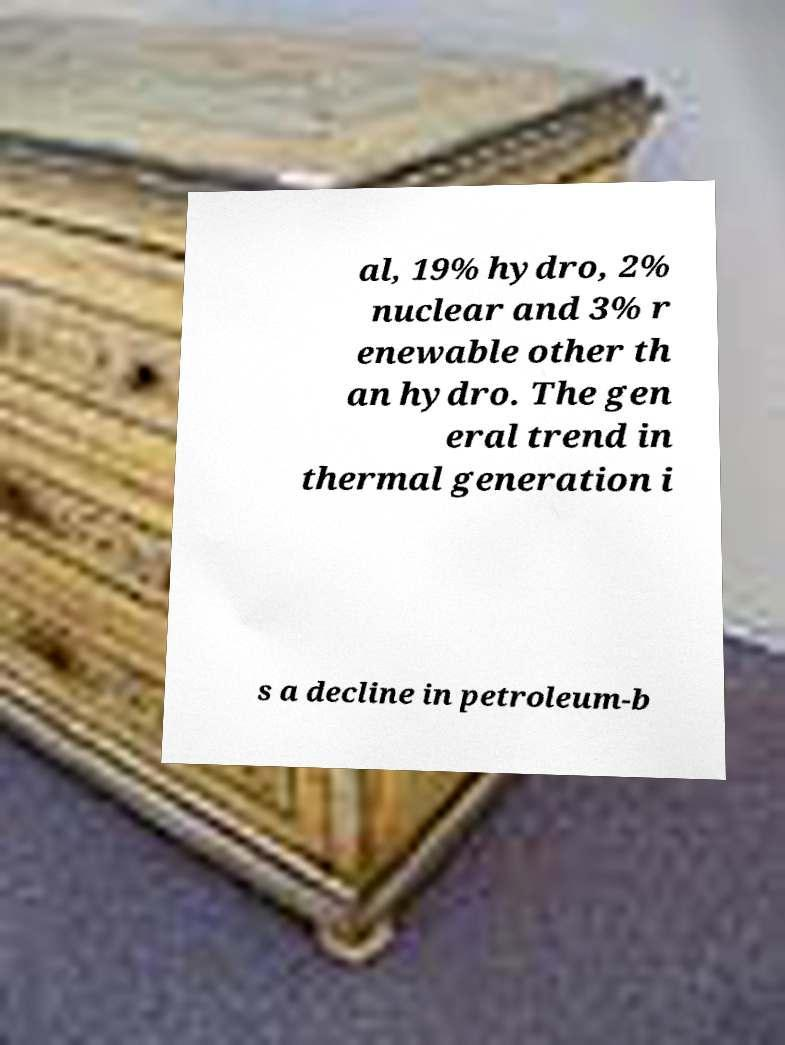For documentation purposes, I need the text within this image transcribed. Could you provide that? al, 19% hydro, 2% nuclear and 3% r enewable other th an hydro. The gen eral trend in thermal generation i s a decline in petroleum-b 